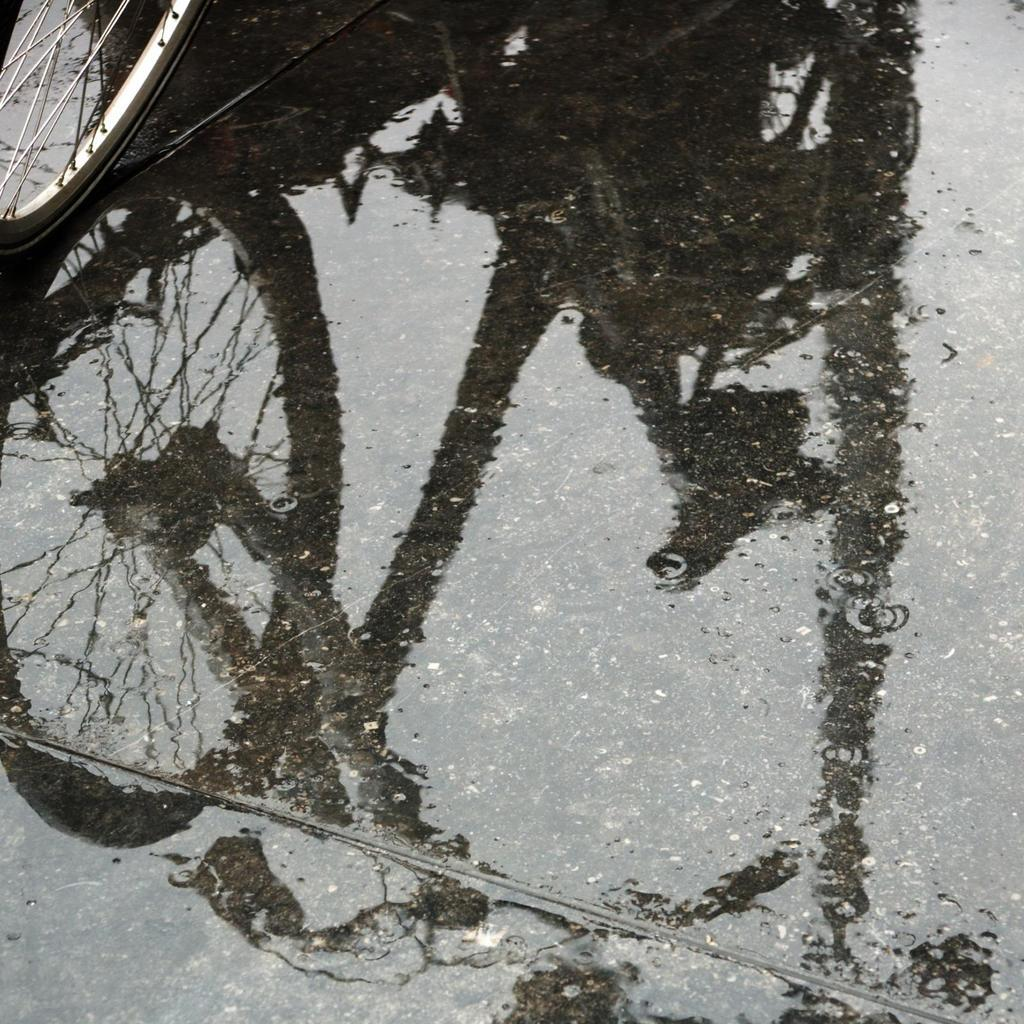What object is located on the left side of the image? There is a wheel on the left side of the image. What is reflected in the water in the image? There is a reflection of a bicycle on the water in the image. Where is the water located in the image? The water is on the floor in the image. What type of flower can be seen growing in the downtown area in the image? There is no downtown area or flower present in the image. How does the person in the image pull the bicycle out of the water? There is no person present in the image, and the bicycle is only reflected in the water, not submerged. 